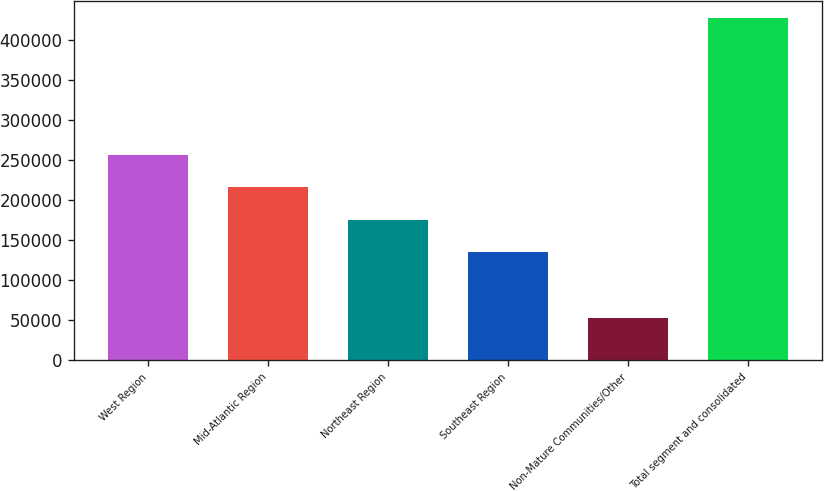Convert chart. <chart><loc_0><loc_0><loc_500><loc_500><bar_chart><fcel>West Region<fcel>Mid-Atlantic Region<fcel>Northeast Region<fcel>Southeast Region<fcel>Non-Mature Communities/Other<fcel>Total segment and consolidated<nl><fcel>256672<fcel>215996<fcel>175320<fcel>134644<fcel>53291.2<fcel>427221<nl></chart> 